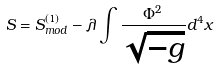<formula> <loc_0><loc_0><loc_500><loc_500>S = S _ { m o d } ^ { ( 1 ) } - \lambda \int \frac { \Phi ^ { 2 } } { \sqrt { - g } } d ^ { 4 } x</formula> 